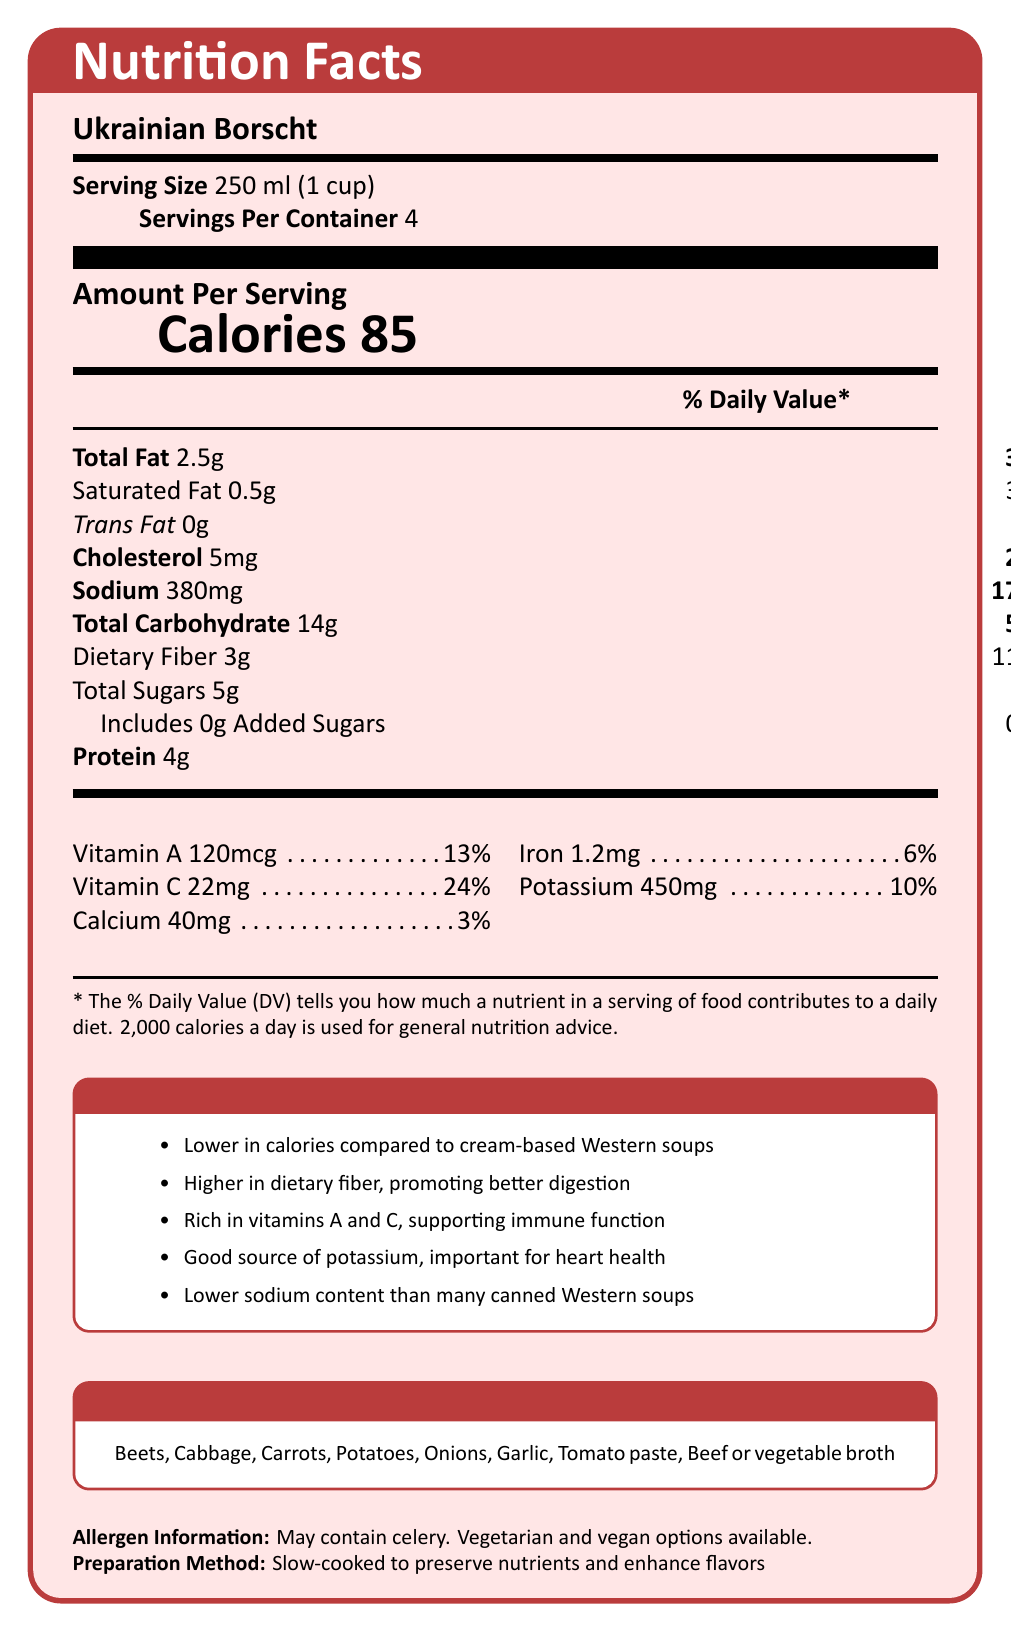how many calories are there in one serving of Ukrainian Borscht? The document indicates that there are 85 calories per serving.
Answer: 85 what percentage of the daily value for dietary fiber does one serving of Ukrainian Borscht provide? The document shows that one serving provides 11% of the daily value for dietary fiber.
Answer: 11% what is the total fat content in one serving of Ukrainian Borscht? The document lists the total fat content as 2.5g per serving.
Answer: 2.5g which Western soup has higher sodium content, cream of mushroom or chicken noodle? The document shows that cream of mushroom has 870mg of sodium, while chicken noodle has 930mg of sodium.
Answer: Chicken noodle which nutrient is found in higher concentration in Ukrainian Borscht compared to Western soups? A. Total carbohydrates B. Calcium C. Vitamin C D. Iron Vitamin C is higher in Ukrainian Borscht compared to Western soups as mentioned in the health benefits section.
Answer: C what are the health benefits of Ukrainian Borscht stated in the document? A. Low in sodium B. Rich in vitamins A and C C. Higher in dietary fiber D. All of the above All of the given options are listed as health benefits of Ukrainian Borscht in the document.
Answer: D is the preparation method of Ukrainian Borscht listed in the document? The document states that the preparation method is slow-cooked to preserve nutrients and enhance flavors.
Answer: Yes describe the main idea of the document. The document provides detailed information about the nutritional content of Ukrainian Borscht, emphasizing its health benefits compared to some common Western soups. It also mentions the preparation method and key ingredients, highlighting the advantages of including this dish in the diet.
Answer: The document outlines the nutrition facts, health benefits, key ingredients, and allergen information for Ukrainian Borscht, comparing its nutritional profile with that of Western soups like cream of mushroom and chicken noodle. does the document provide a comparison of cholesterol content between Ukrainian Borscht and Western soups? The document does not provide cholesterol content for the cream of mushroom or chicken noodle soups, only for Ukrainian Borscht.
Answer: No what is the daily value percentage of sodium in one serving of Ukrainian Borscht? The document states that one serving of Ukrainian Borscht contains 380mg of sodium, which is 17% of the daily value.
Answer: 17% 